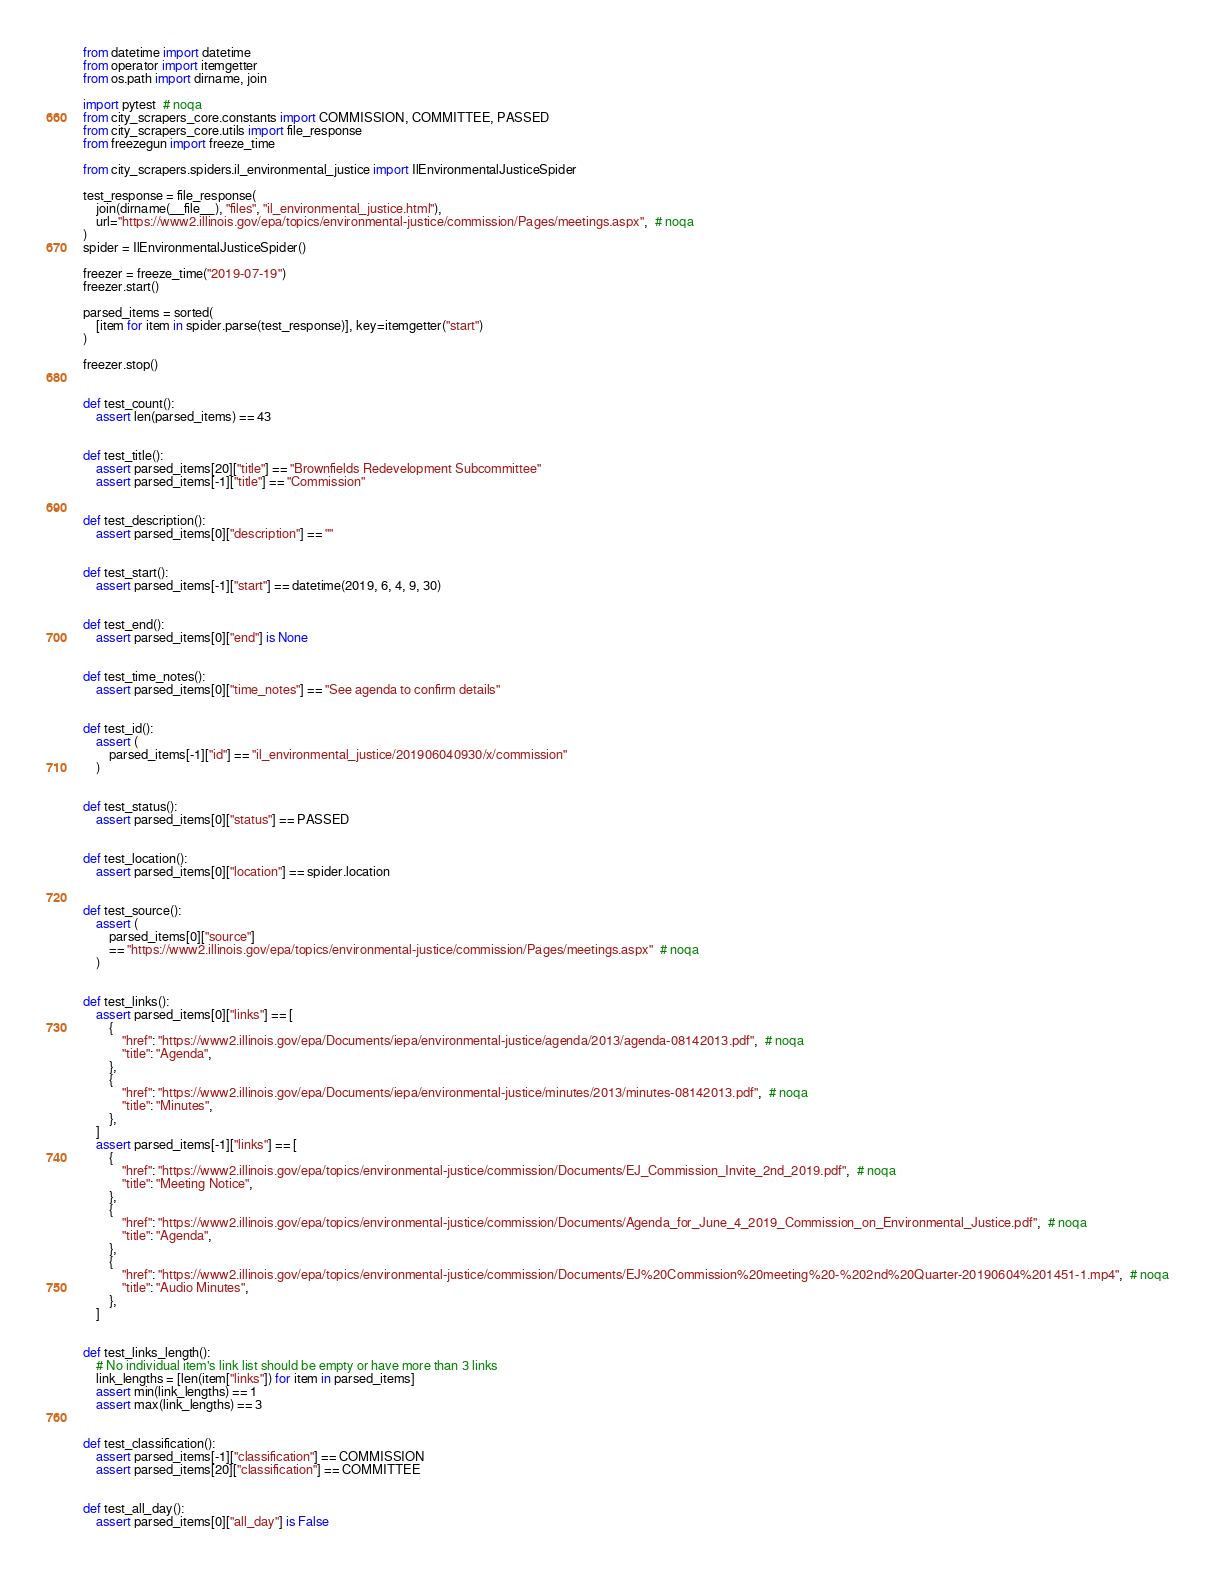<code> <loc_0><loc_0><loc_500><loc_500><_Python_>from datetime import datetime
from operator import itemgetter
from os.path import dirname, join

import pytest  # noqa
from city_scrapers_core.constants import COMMISSION, COMMITTEE, PASSED
from city_scrapers_core.utils import file_response
from freezegun import freeze_time

from city_scrapers.spiders.il_environmental_justice import IlEnvironmentalJusticeSpider

test_response = file_response(
    join(dirname(__file__), "files", "il_environmental_justice.html"),
    url="https://www2.illinois.gov/epa/topics/environmental-justice/commission/Pages/meetings.aspx",  # noqa
)
spider = IlEnvironmentalJusticeSpider()

freezer = freeze_time("2019-07-19")
freezer.start()

parsed_items = sorted(
    [item for item in spider.parse(test_response)], key=itemgetter("start")
)

freezer.stop()


def test_count():
    assert len(parsed_items) == 43


def test_title():
    assert parsed_items[20]["title"] == "Brownfields Redevelopment Subcommittee"
    assert parsed_items[-1]["title"] == "Commission"


def test_description():
    assert parsed_items[0]["description"] == ""


def test_start():
    assert parsed_items[-1]["start"] == datetime(2019, 6, 4, 9, 30)


def test_end():
    assert parsed_items[0]["end"] is None


def test_time_notes():
    assert parsed_items[0]["time_notes"] == "See agenda to confirm details"


def test_id():
    assert (
        parsed_items[-1]["id"] == "il_environmental_justice/201906040930/x/commission"
    )


def test_status():
    assert parsed_items[0]["status"] == PASSED


def test_location():
    assert parsed_items[0]["location"] == spider.location


def test_source():
    assert (
        parsed_items[0]["source"]
        == "https://www2.illinois.gov/epa/topics/environmental-justice/commission/Pages/meetings.aspx"  # noqa
    )


def test_links():
    assert parsed_items[0]["links"] == [
        {
            "href": "https://www2.illinois.gov/epa/Documents/iepa/environmental-justice/agenda/2013/agenda-08142013.pdf",  # noqa
            "title": "Agenda",
        },
        {
            "href": "https://www2.illinois.gov/epa/Documents/iepa/environmental-justice/minutes/2013/minutes-08142013.pdf",  # noqa
            "title": "Minutes",
        },
    ]
    assert parsed_items[-1]["links"] == [
        {
            "href": "https://www2.illinois.gov/epa/topics/environmental-justice/commission/Documents/EJ_Commission_Invite_2nd_2019.pdf",  # noqa
            "title": "Meeting Notice",
        },
        {
            "href": "https://www2.illinois.gov/epa/topics/environmental-justice/commission/Documents/Agenda_for_June_4_2019_Commission_on_Environmental_Justice.pdf",  # noqa
            "title": "Agenda",
        },
        {
            "href": "https://www2.illinois.gov/epa/topics/environmental-justice/commission/Documents/EJ%20Commission%20meeting%20-%202nd%20Quarter-20190604%201451-1.mp4",  # noqa
            "title": "Audio Minutes",
        },
    ]


def test_links_length():
    # No individual item's link list should be empty or have more than 3 links
    link_lengths = [len(item["links"]) for item in parsed_items]
    assert min(link_lengths) == 1
    assert max(link_lengths) == 3


def test_classification():
    assert parsed_items[-1]["classification"] == COMMISSION
    assert parsed_items[20]["classification"] == COMMITTEE


def test_all_day():
    assert parsed_items[0]["all_day"] is False
</code> 